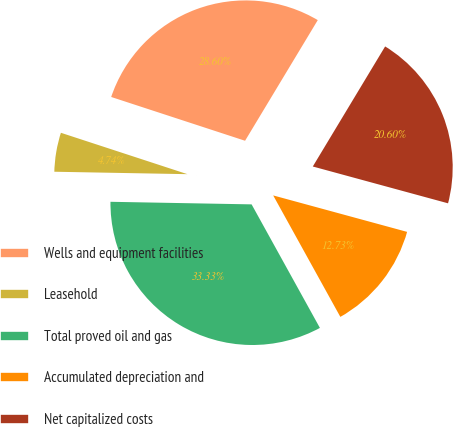Convert chart to OTSL. <chart><loc_0><loc_0><loc_500><loc_500><pie_chart><fcel>Wells and equipment facilities<fcel>Leasehold<fcel>Total proved oil and gas<fcel>Accumulated depreciation and<fcel>Net capitalized costs<nl><fcel>28.6%<fcel>4.74%<fcel>33.33%<fcel>12.73%<fcel>20.6%<nl></chart> 